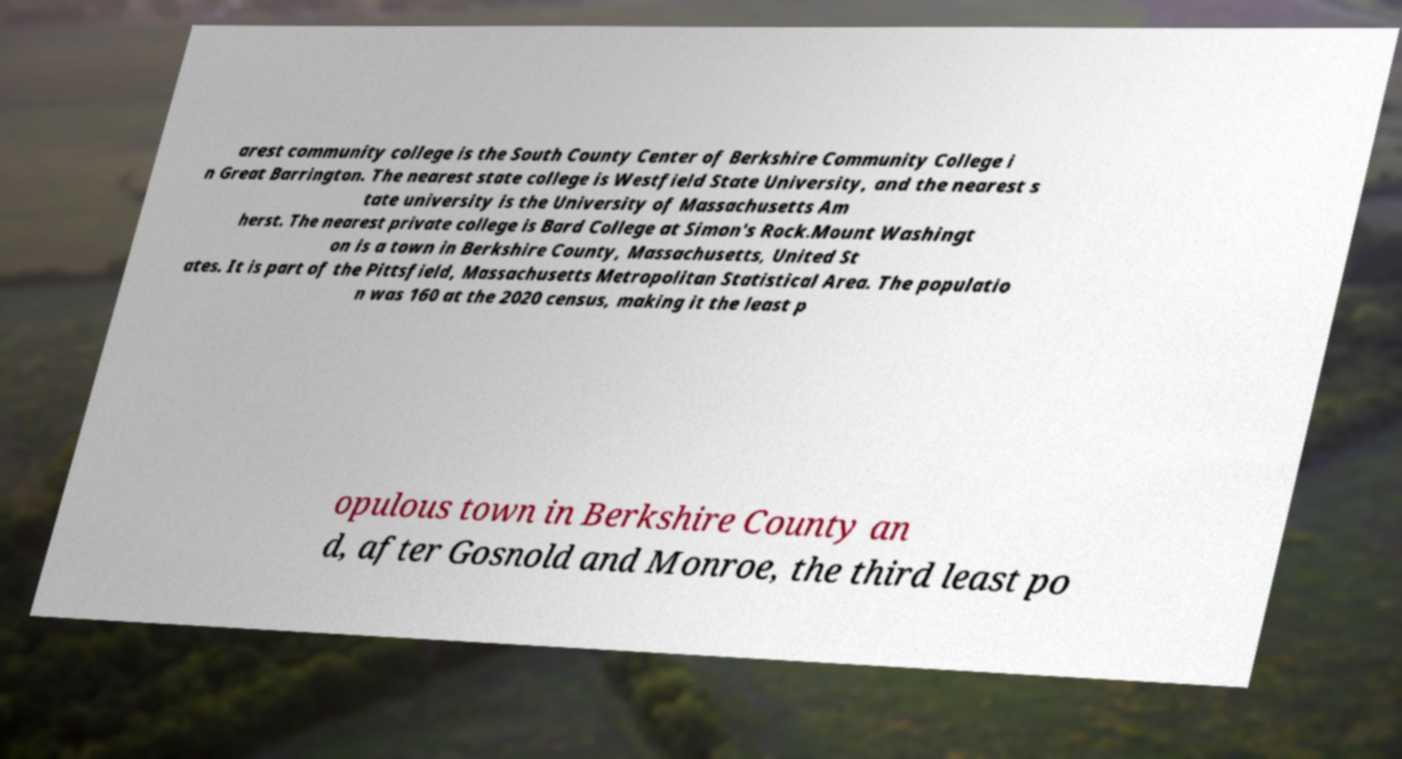Could you extract and type out the text from this image? arest community college is the South County Center of Berkshire Community College i n Great Barrington. The nearest state college is Westfield State University, and the nearest s tate university is the University of Massachusetts Am herst. The nearest private college is Bard College at Simon's Rock.Mount Washingt on is a town in Berkshire County, Massachusetts, United St ates. It is part of the Pittsfield, Massachusetts Metropolitan Statistical Area. The populatio n was 160 at the 2020 census, making it the least p opulous town in Berkshire County an d, after Gosnold and Monroe, the third least po 